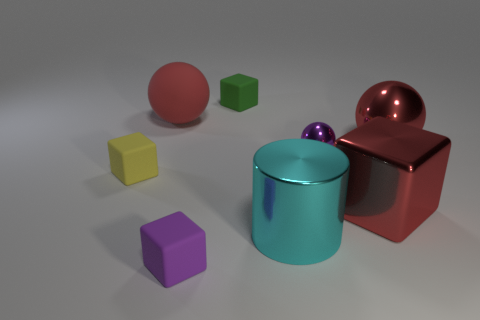How would you describe the lighting and shadow effect in the scene? The lighting in the scene creates a soft ambiance, with diffuse shadows cast to the right of the objects, indicating a light source to the left. The shadows are gently blurred, contributing to the scene's overall calm and balanced aesthetic. 